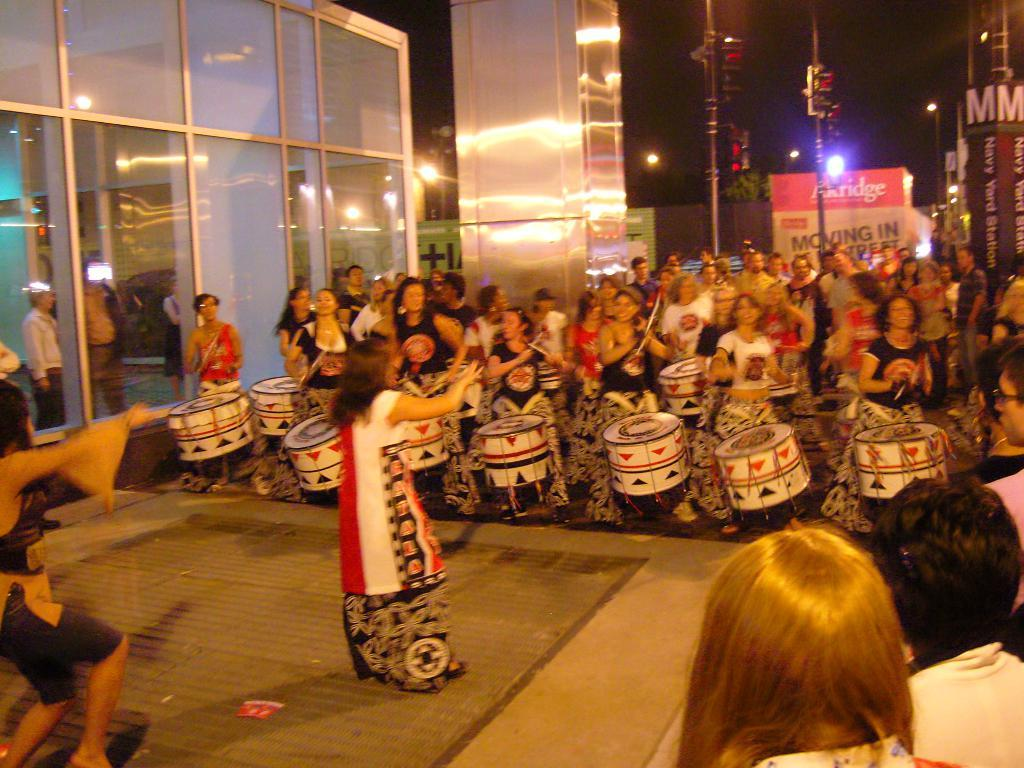What are the persons in the image doing? The persons in the image are standing and playing drums. Can you describe the woman in the image? There is a woman standing in the image. What type of architectural feature can be seen in the image? There are glass doors in the image. What can be seen in the image that provides illumination? There are lights visible in the image. What scientific discovery is being made by the persons playing drums in the image? There is no indication in the image that the persons playing drums are making a scientific discovery. 